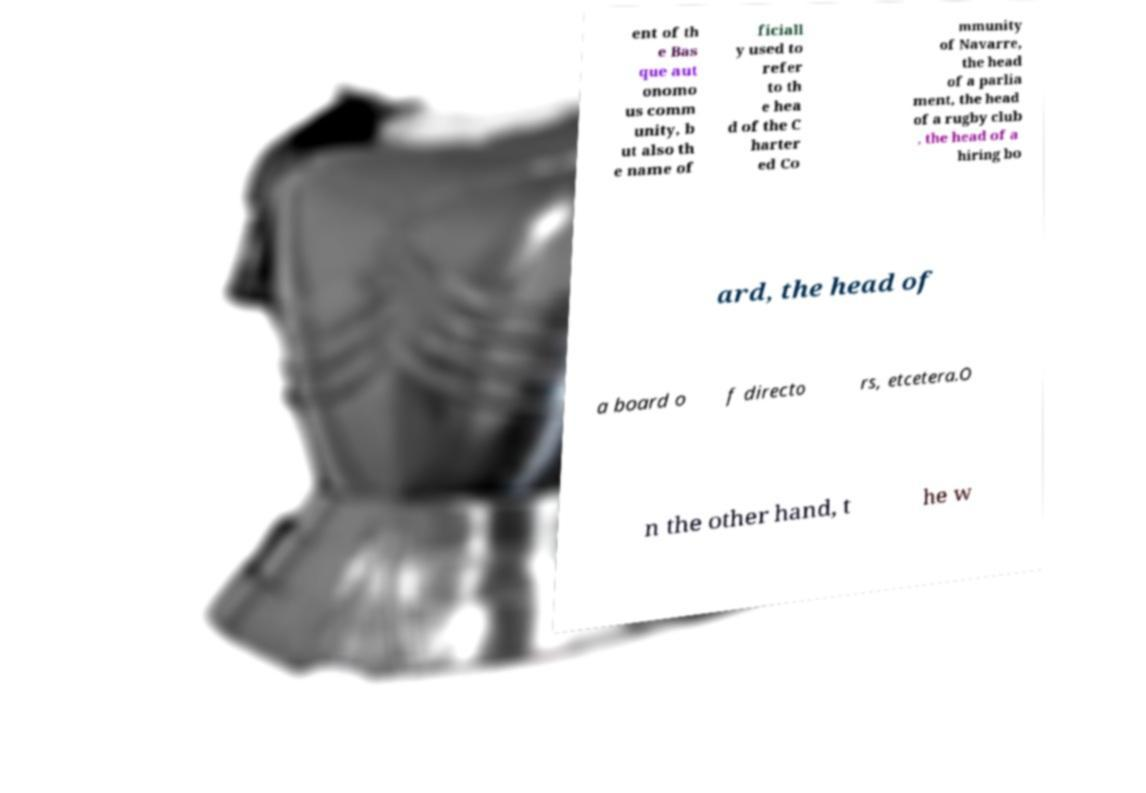For documentation purposes, I need the text within this image transcribed. Could you provide that? ent of th e Bas que aut onomo us comm unity, b ut also th e name of ficiall y used to refer to th e hea d of the C harter ed Co mmunity of Navarre, the head of a parlia ment, the head of a rugby club , the head of a hiring bo ard, the head of a board o f directo rs, etcetera.O n the other hand, t he w 